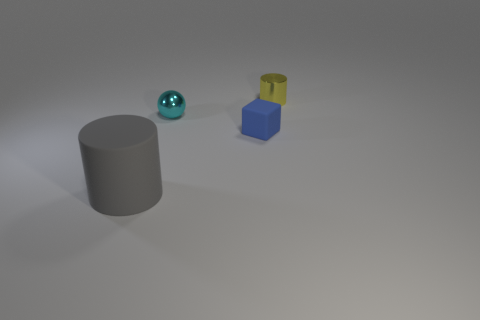Can you describe the orientation and relative positions of the objects depicted in the image? Certainly! In the image, there are three primary objects arranged on a flat surface. From left to right, as we view the scene, there is a tall grey cylinder, a reflective metal sphere, and to the right is a pair of stacked blocks—a blue cube on the bottom and a smaller yellow cylinder on top. 